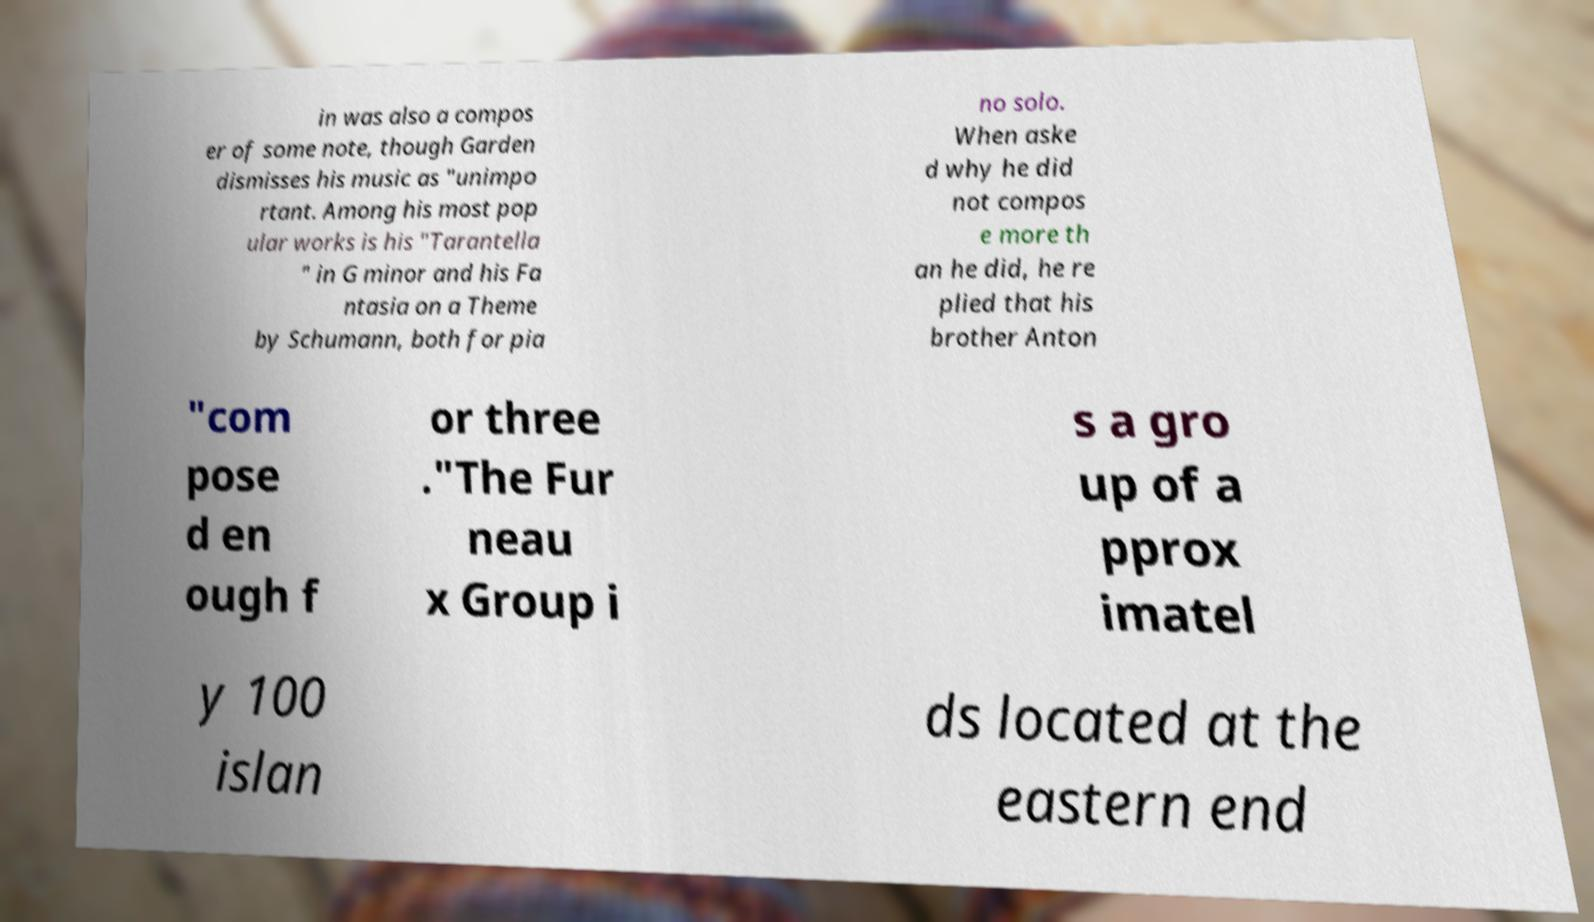Please identify and transcribe the text found in this image. in was also a compos er of some note, though Garden dismisses his music as "unimpo rtant. Among his most pop ular works is his "Tarantella " in G minor and his Fa ntasia on a Theme by Schumann, both for pia no solo. When aske d why he did not compos e more th an he did, he re plied that his brother Anton "com pose d en ough f or three ."The Fur neau x Group i s a gro up of a pprox imatel y 100 islan ds located at the eastern end 